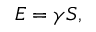Convert formula to latex. <formula><loc_0><loc_0><loc_500><loc_500>E = \gamma S ,</formula> 